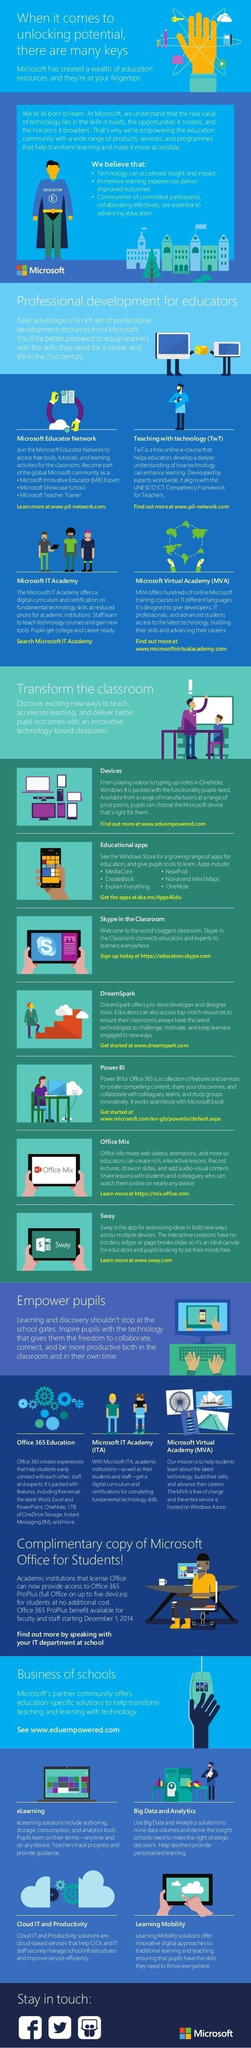Which initiative of Microsoft helps students upgrade their skills free of cost, Microsoft Educator Network, Microsoft Virtual Academy, or  Microsoft IT Academy?
Answer the question with a short phrase. MVA Which three technology tools used for education are displayed on the screen of the tablet? Skype in the Classroom, Office Mix, Sway 